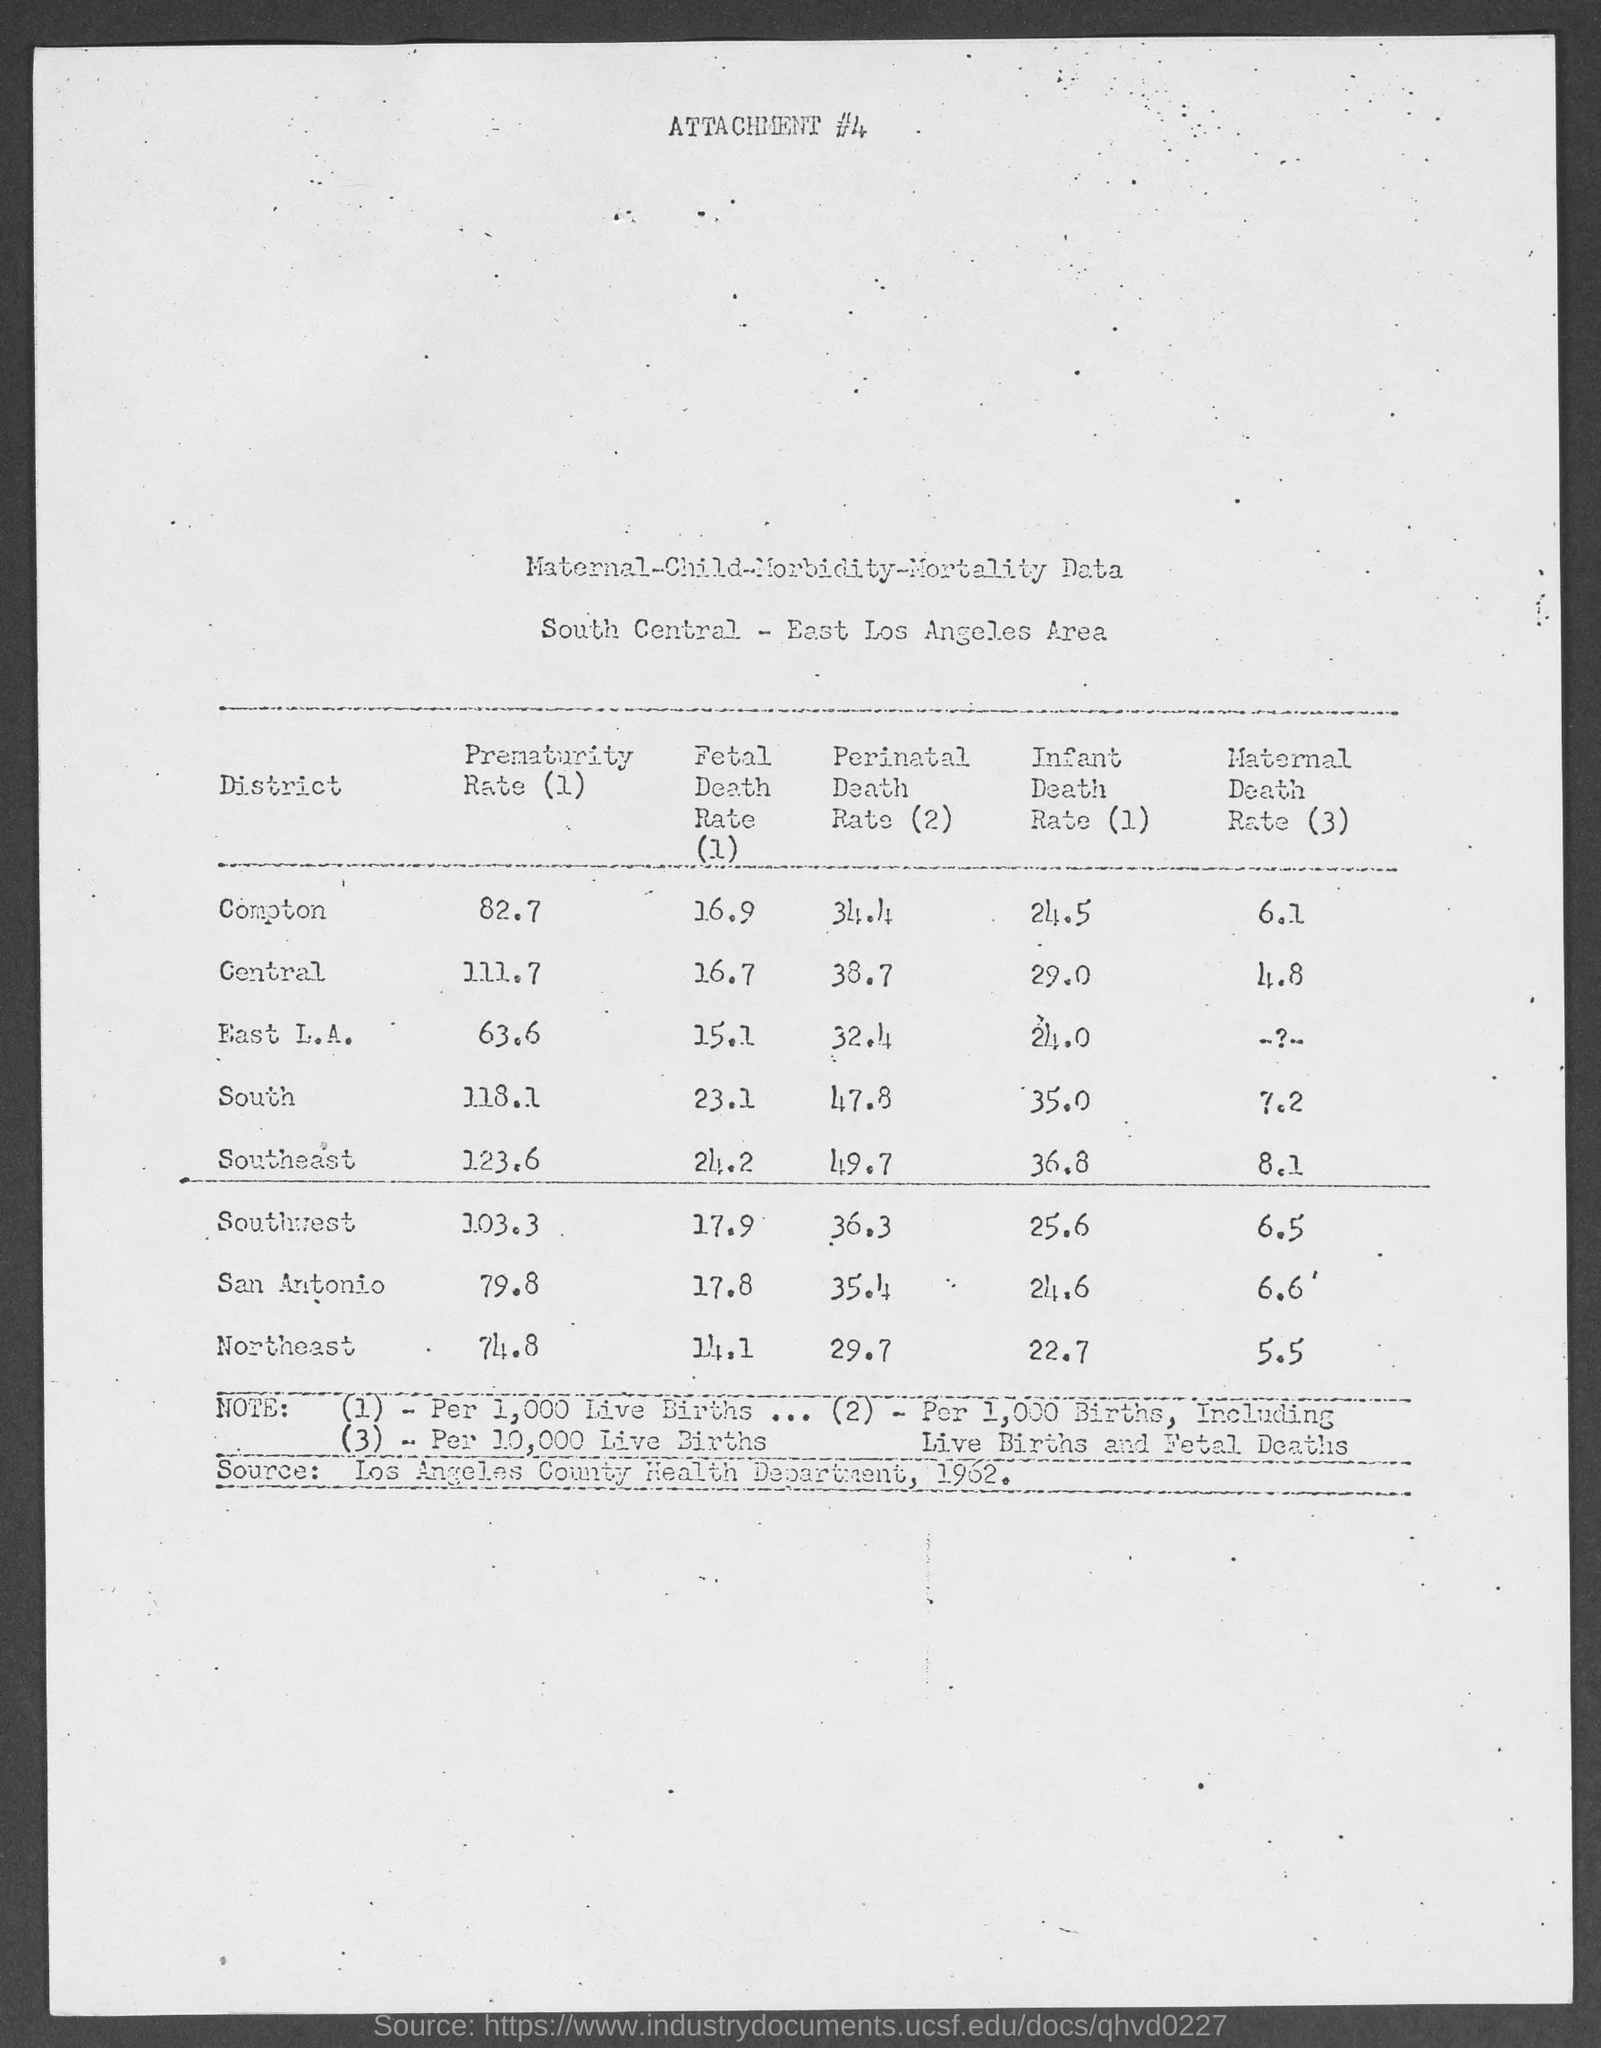Point out several critical features in this image. The fetal death rate in Compton, as mentioned in the given table, is 16.9. The fetal death rate in Central, as mentioned in the given table, is 16.7 per 1,000 live births. According to the given page, the prematurity rate in Compton is 82.7%. The prematurity rate in Central is 111.7%, as mentioned in the given table. According to the given table, the infant death rate in Central state is 29.0 per 1,000 live births. 